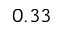Convert formula to latex. <formula><loc_0><loc_0><loc_500><loc_500>0 . 3 3</formula> 